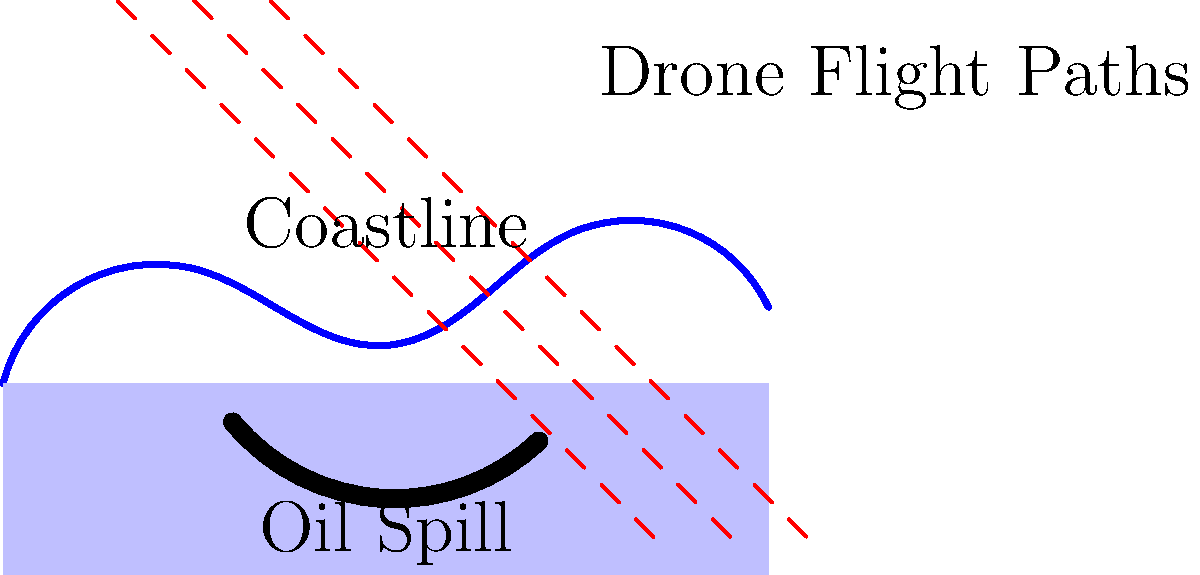In the image above, three parallel drone flight paths are shown over an oil spill in a marine environment. If the distance between each flight path is 500 meters and the width of the oil spill perpendicular to the flight paths is approximately 2.5 flight path intervals, what is the estimated width of the oil spill in kilometers? To solve this problem, we need to follow these steps:

1. Identify the given information:
   - The distance between each flight path is 500 meters
   - The width of the oil spill is approximately 2.5 flight path intervals

2. Calculate the width of the oil spill in meters:
   - One flight path interval = 500 meters
   - Width of oil spill = 2.5 × 500 meters
   - Width of oil spill = 1250 meters

3. Convert the width from meters to kilometers:
   - 1 kilometer = 1000 meters
   - Width in kilometers = 1250 ÷ 1000
   - Width in kilometers = 1.25 km

Therefore, the estimated width of the oil spill is 1.25 kilometers.
Answer: 1.25 km 